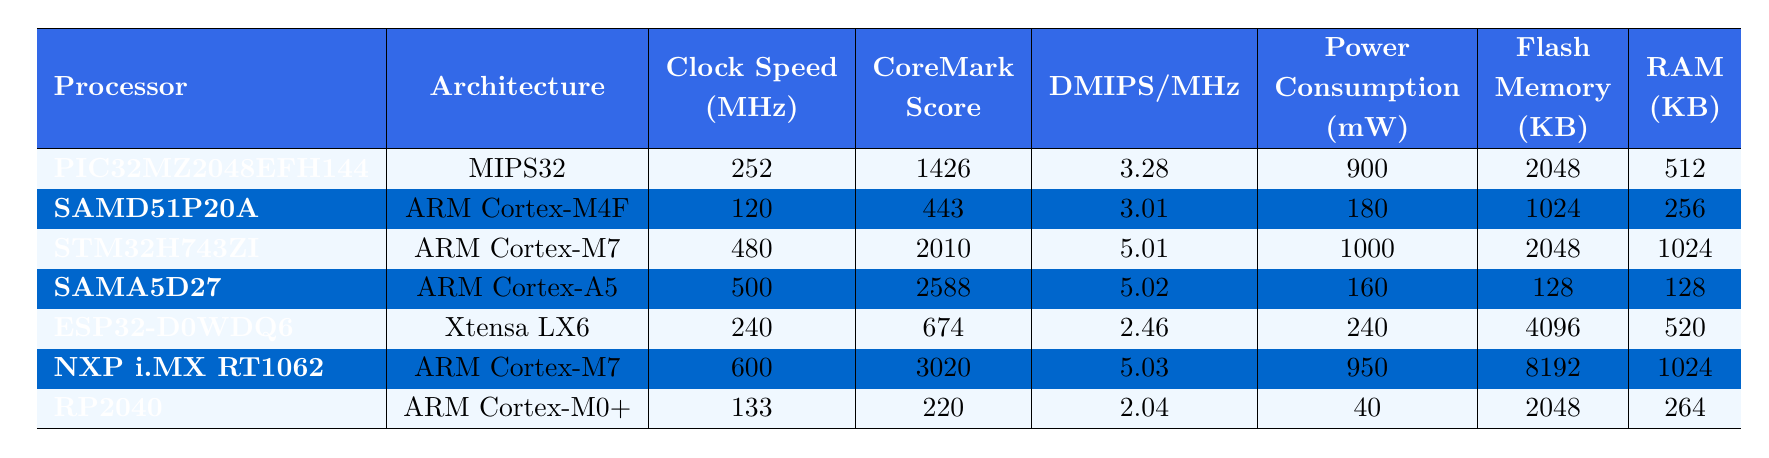What is the CoreMark score for the STM32H743ZI processor? The CoreMark score is directly listed in the table. For the STM32H743ZI processor, the score is 2010.
Answer: 2010 Which processor has the highest clock speed? To find the processor with the highest clock speed, I compare the "Clock Speed (MHz)" values in the table. The NXP i.MX RT1062 has the highest clock speed of 600 MHz.
Answer: NXP i.MX RT1062 How much RAM does the SAMA5D27 processor have compared to the ESP32-D0WDQ6? The RAM for SAMA5D27 is 128 KB and for ESP32-D0WDQ6 it is 520 KB. To compare, I calculate 520 - 128 = 392, so ESP32-D0WDQ6 has 392 KB more RAM than SAMA5D27.
Answer: 392 KB What is the total power consumption of the two ARM Cortex-M7 processors? The two ARM Cortex-M7 processors are STM32H743ZI with a power consumption of 1000 mW and NXP i.MX RT1062 with 950 mW. I add these values: 1000 + 950 = 1950 mW.
Answer: 1950 mW Is the DMIPS/MHz of the SAMD51P20A greater than 3? The DMIPS/MHz for SAMD51P20A is 3.01. Since 3.01 is greater than 3, the statement is true.
Answer: Yes Which processor has the lowest power consumption? I look for the lowest value in the "Power Consumption (mW)" column. The RP2040 has a power consumption of 40 mW, which is the lowest.
Answer: RP2040 What is the average clock speed of all processors listed in the table? I add the clock speeds of all processors: 252 + 120 + 480 + 500 + 240 + 600 + 133 = 2325 MHz. There are 7 processors, so I divide 2325 by 7, giving an average of approximately 331.43 MHz.
Answer: 331.43 MHz How many processors have more than 512 KB of Flash Memory? I check the "Flash Memory (KB)" column for values greater than 512 KB. The processors with more than 512 KB are PIC32MZ2048EFH144 (2048 KB), STM32H743ZI (2048 KB), ESP32-D0WDQ6 (4096 KB), and NXP i.MX RT1062 (8192 KB). This gives a count of 4.
Answer: 4 What is the difference in CoreMark score between the highest and lowest scoring processors? The highest CoreMark score is for NXP i.MX RT1062 with 3020 and the lowest is for RP2040 with 220. The difference is 3020 - 220 = 2800.
Answer: 2800 Which architecture has the lowest average power consumption? I will calculate the average power consumption for each architecture by considering the respective processors. MIPS32: 900 mW, ARM Cortex-M4F: 180 mW, ARM Cortex-M7: (1000 + 950)/2 = 975 mW, ARM Cortex-A5: 160 mW, Xtensa LX6: 240 mW, ARM Cortex-M0+: 40 mW. The lowest average is for ARM Cortex-M0+, which is 40 mW.
Answer: ARM Cortex-M0+ 